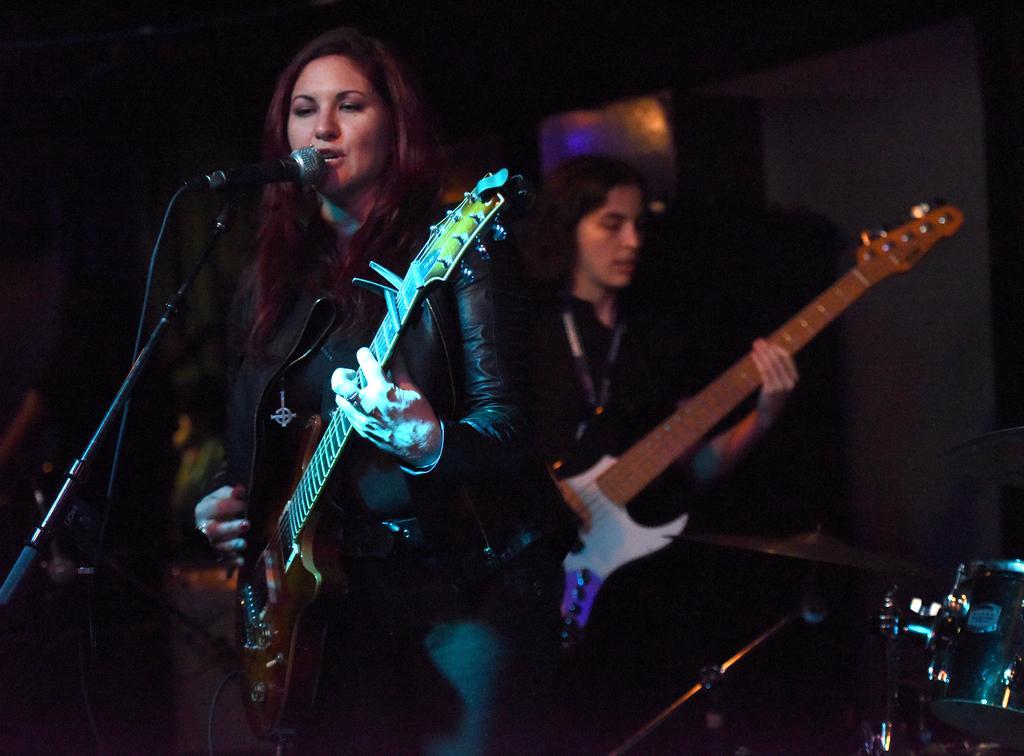How would you summarize this image in a sentence or two? In this picture there are two women standing and playing guitars in their hands. One of the woman is standing in front of a mic and a stand. In the background there are some speakers and a wall here. 